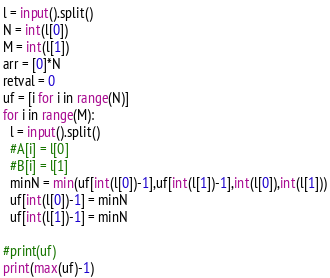Convert code to text. <code><loc_0><loc_0><loc_500><loc_500><_Python_>l = input().split()
N = int(l[0])
M = int(l[1])
arr = [0]*N
retval = 0
uf = [i for i in range(N)]
for i in range(M):
  l = input().split()
  #A[i] = l[0]
  #B[i] = l[1]
  minN = min(uf[int(l[0])-1],uf[int(l[1])-1],int(l[0]),int(l[1]))
  uf[int(l[0])-1] = minN
  uf[int(l[1])-1] = minN

#print(uf)
print(max(uf)-1)</code> 